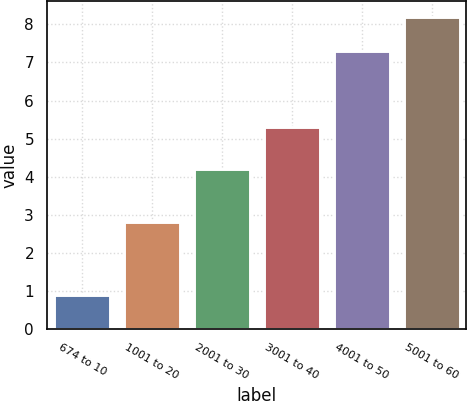Convert chart to OTSL. <chart><loc_0><loc_0><loc_500><loc_500><bar_chart><fcel>674 to 10<fcel>1001 to 20<fcel>2001 to 30<fcel>3001 to 40<fcel>4001 to 50<fcel>5001 to 60<nl><fcel>0.9<fcel>2.8<fcel>4.2<fcel>5.3<fcel>7.3<fcel>8.2<nl></chart> 